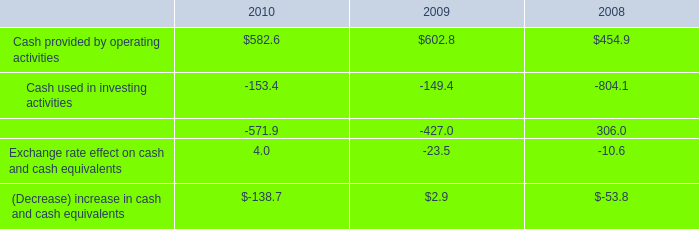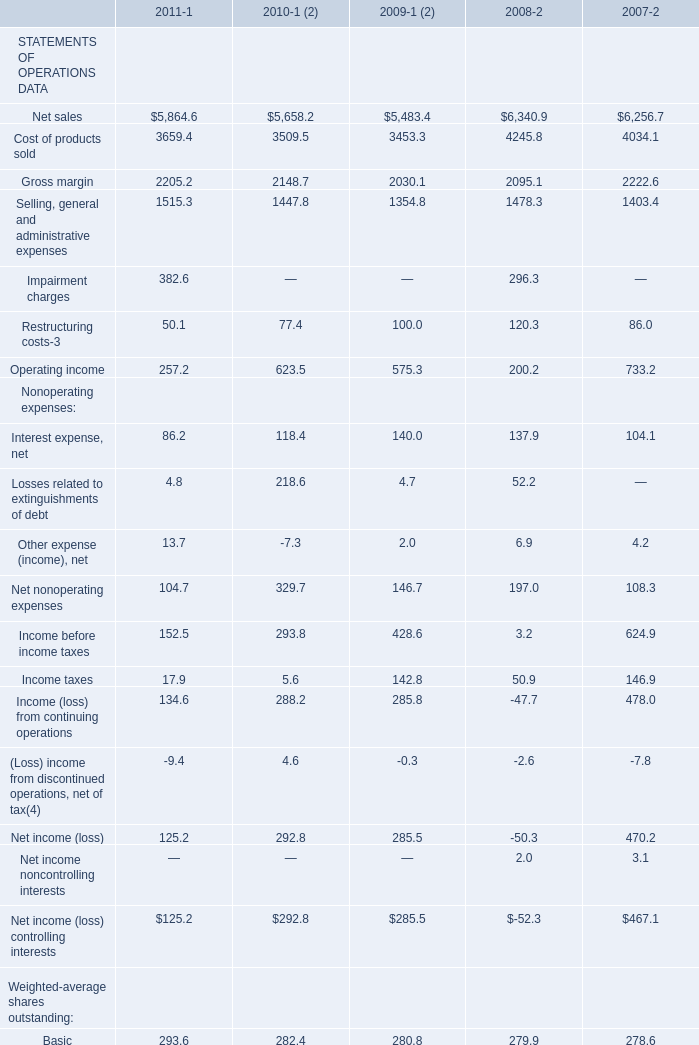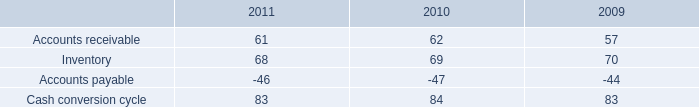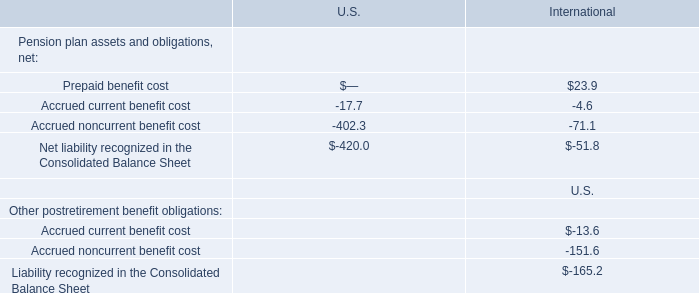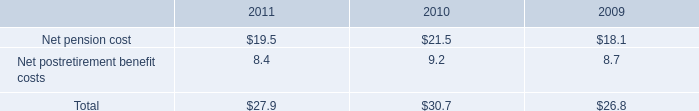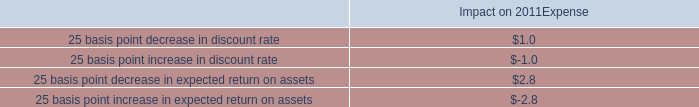What is the growing rate of Basic of Weighted-average shares outstanding in the year with the least Net income (loss) controlling interests? 
Computations: ((280.8 - 279.9) / 279.9)
Answer: 0.00322. 